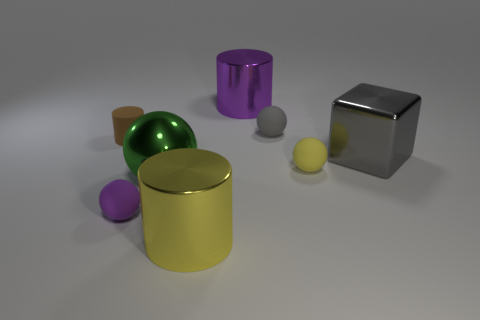Subtract all big green metallic spheres. How many spheres are left? 3 Subtract all yellow balls. How many balls are left? 3 Add 2 purple cylinders. How many objects exist? 10 Subtract 1 spheres. How many spheres are left? 3 Subtract all gray balls. Subtract all gray cubes. How many balls are left? 3 Subtract all cylinders. How many objects are left? 5 Subtract all big blue matte spheres. Subtract all blocks. How many objects are left? 7 Add 7 large cubes. How many large cubes are left? 8 Add 2 tiny gray spheres. How many tiny gray spheres exist? 3 Subtract 1 green spheres. How many objects are left? 7 